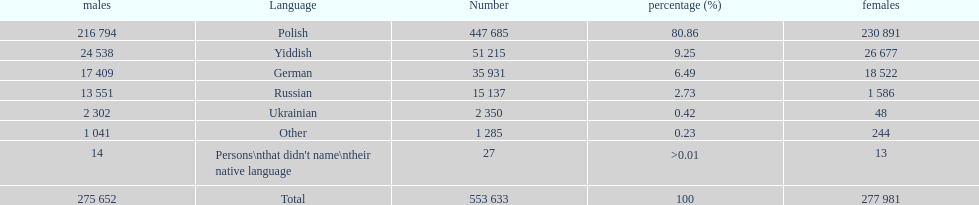What was the least spoken language Ukrainian. What was the most spoken? Polish. 